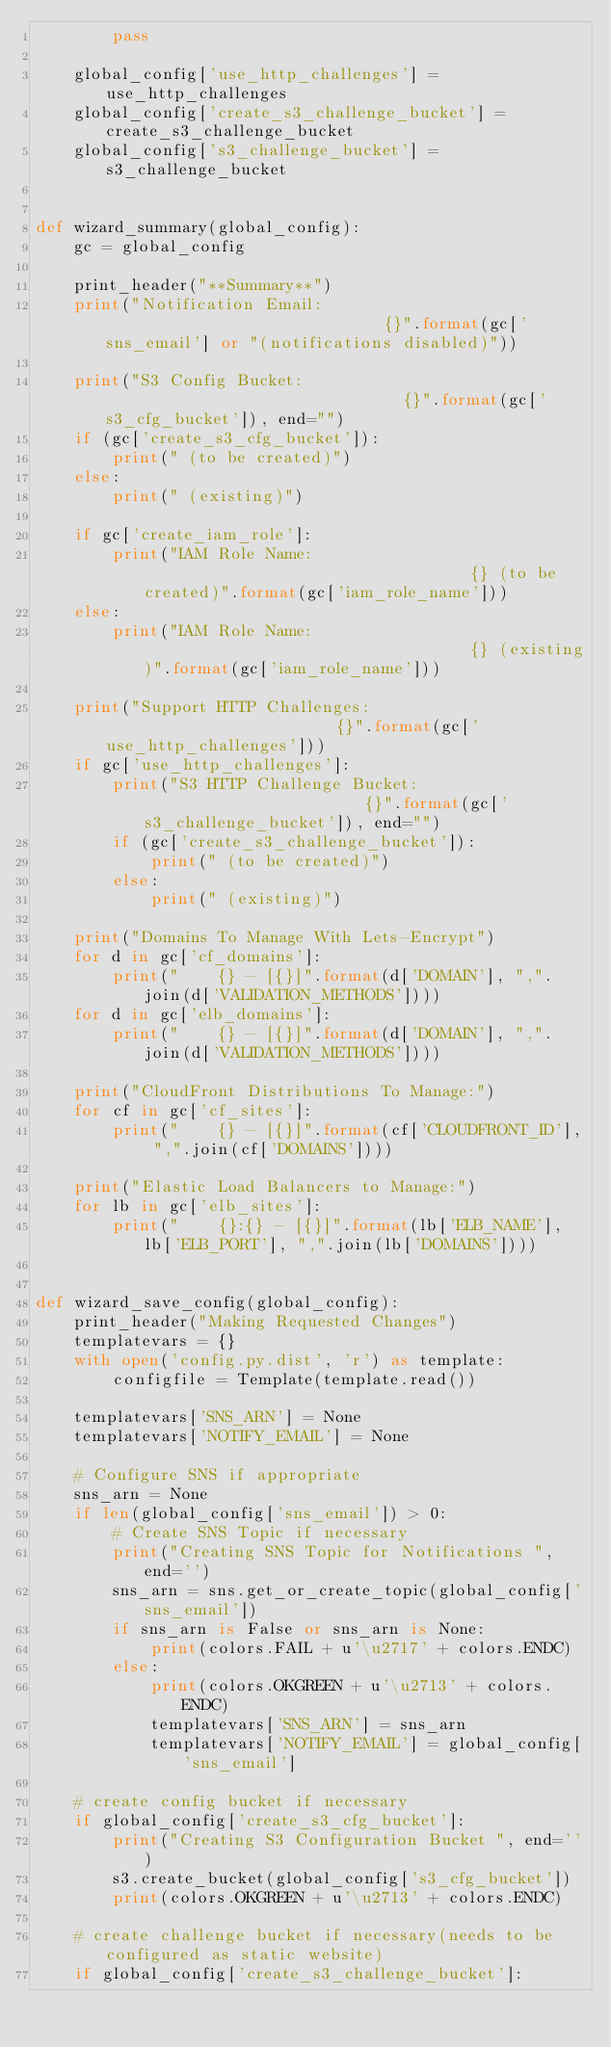Convert code to text. <code><loc_0><loc_0><loc_500><loc_500><_Python_>        pass

    global_config['use_http_challenges'] = use_http_challenges
    global_config['create_s3_challenge_bucket'] = create_s3_challenge_bucket
    global_config['s3_challenge_bucket'] = s3_challenge_bucket


def wizard_summary(global_config):
    gc = global_config

    print_header("**Summary**")
    print("Notification Email:                              {}".format(gc['sns_email'] or "(notifications disabled)"))

    print("S3 Config Bucket:                                {}".format(gc['s3_cfg_bucket']), end="")
    if (gc['create_s3_cfg_bucket']):
        print(" (to be created)")
    else:
        print(" (existing)")

    if gc['create_iam_role']:
        print("IAM Role Name:                                   {} (to be created)".format(gc['iam_role_name']))
    else:
        print("IAM Role Name:                                   {} (existing)".format(gc['iam_role_name']))

    print("Support HTTP Challenges:                         {}".format(gc['use_http_challenges']))
    if gc['use_http_challenges']:
        print("S3 HTTP Challenge Bucket:                        {}".format(gc['s3_challenge_bucket']), end="")
        if (gc['create_s3_challenge_bucket']):
            print(" (to be created)")
        else:
            print(" (existing)")

    print("Domains To Manage With Lets-Encrypt")
    for d in gc['cf_domains']:
        print("    {} - [{}]".format(d['DOMAIN'], ",".join(d['VALIDATION_METHODS'])))
    for d in gc['elb_domains']:
        print("    {} - [{}]".format(d['DOMAIN'], ",".join(d['VALIDATION_METHODS'])))

    print("CloudFront Distributions To Manage:")
    for cf in gc['cf_sites']:
        print("    {} - [{}]".format(cf['CLOUDFRONT_ID'], ",".join(cf['DOMAINS'])))

    print("Elastic Load Balancers to Manage:")
    for lb in gc['elb_sites']:
        print("    {}:{} - [{}]".format(lb['ELB_NAME'], lb['ELB_PORT'], ",".join(lb['DOMAINS'])))


def wizard_save_config(global_config):
    print_header("Making Requested Changes")
    templatevars = {}
    with open('config.py.dist', 'r') as template:
        configfile = Template(template.read())

    templatevars['SNS_ARN'] = None
    templatevars['NOTIFY_EMAIL'] = None

    # Configure SNS if appropriate
    sns_arn = None
    if len(global_config['sns_email']) > 0:
        # Create SNS Topic if necessary
        print("Creating SNS Topic for Notifications ", end='')
        sns_arn = sns.get_or_create_topic(global_config['sns_email'])
        if sns_arn is False or sns_arn is None:
            print(colors.FAIL + u'\u2717' + colors.ENDC)
        else:
            print(colors.OKGREEN + u'\u2713' + colors.ENDC)
            templatevars['SNS_ARN'] = sns_arn
            templatevars['NOTIFY_EMAIL'] = global_config['sns_email']

    # create config bucket if necessary
    if global_config['create_s3_cfg_bucket']:
        print("Creating S3 Configuration Bucket ", end='')
        s3.create_bucket(global_config['s3_cfg_bucket'])
        print(colors.OKGREEN + u'\u2713' + colors.ENDC)

    # create challenge bucket if necessary(needs to be configured as static website)
    if global_config['create_s3_challenge_bucket']:</code> 